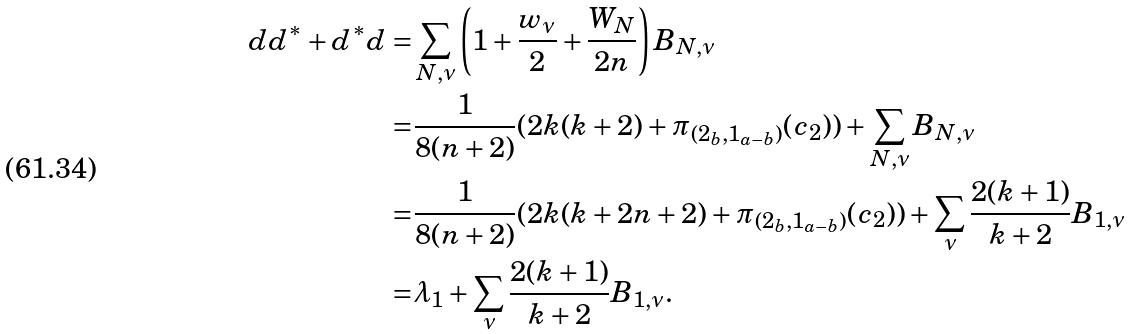Convert formula to latex. <formula><loc_0><loc_0><loc_500><loc_500>d d ^ { \ast } + d ^ { \ast } d = & \sum _ { N , \nu } \left ( 1 + \frac { w _ { \nu } } { 2 } + \frac { W _ { N } } { 2 n } \right ) B _ { N , \nu } \\ = & \frac { 1 } { 8 ( n + 2 ) } ( 2 k ( k + 2 ) + \pi _ { ( 2 _ { b } , 1 _ { a - b } ) } ( c _ { 2 } ) ) + \sum _ { N , \nu } B _ { N , \nu } \\ = & \frac { 1 } { 8 ( n + 2 ) } ( 2 k ( k + 2 n + 2 ) + \pi _ { ( 2 _ { b } , 1 _ { a - b } ) } ( c _ { 2 } ) ) + \sum _ { \nu } \frac { 2 ( k + 1 ) } { k + 2 } B _ { 1 , \nu } \\ = & \lambda _ { 1 } + \sum _ { \nu } \frac { 2 ( k + 1 ) } { k + 2 } B _ { 1 , \nu } .</formula> 